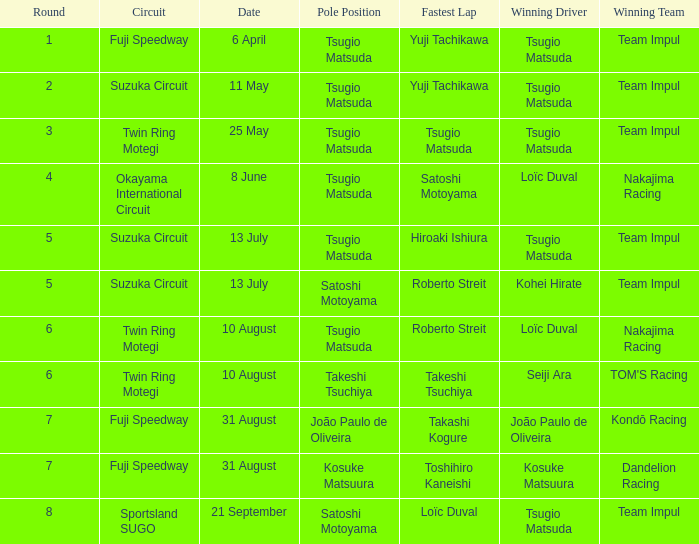What is the fastest lap for Seiji Ara? Takeshi Tsuchiya. 